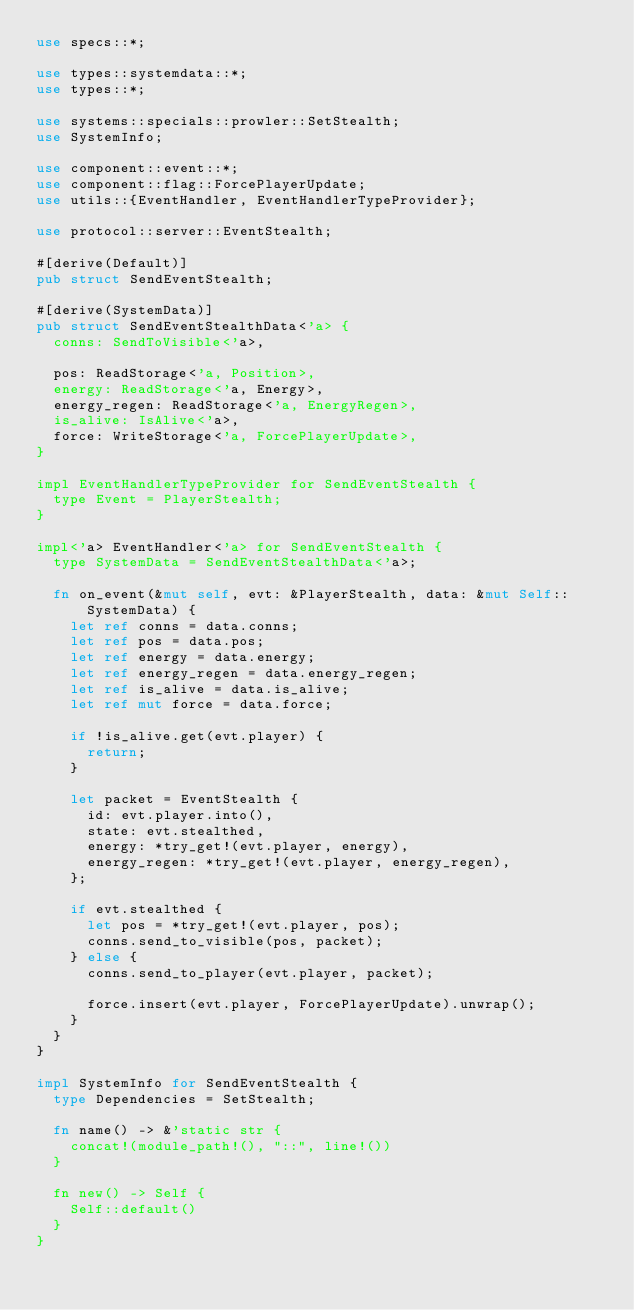Convert code to text. <code><loc_0><loc_0><loc_500><loc_500><_Rust_>use specs::*;

use types::systemdata::*;
use types::*;

use systems::specials::prowler::SetStealth;
use SystemInfo;

use component::event::*;
use component::flag::ForcePlayerUpdate;
use utils::{EventHandler, EventHandlerTypeProvider};

use protocol::server::EventStealth;

#[derive(Default)]
pub struct SendEventStealth;

#[derive(SystemData)]
pub struct SendEventStealthData<'a> {
	conns: SendToVisible<'a>,

	pos: ReadStorage<'a, Position>,
	energy: ReadStorage<'a, Energy>,
	energy_regen: ReadStorage<'a, EnergyRegen>,
	is_alive: IsAlive<'a>,
	force: WriteStorage<'a, ForcePlayerUpdate>,
}

impl EventHandlerTypeProvider for SendEventStealth {
	type Event = PlayerStealth;
}

impl<'a> EventHandler<'a> for SendEventStealth {
	type SystemData = SendEventStealthData<'a>;

	fn on_event(&mut self, evt: &PlayerStealth, data: &mut Self::SystemData) {
		let ref conns = data.conns;
		let ref pos = data.pos;
		let ref energy = data.energy;
		let ref energy_regen = data.energy_regen;
		let ref is_alive = data.is_alive;
		let ref mut force = data.force;

		if !is_alive.get(evt.player) {
			return;
		}

		let packet = EventStealth {
			id: evt.player.into(),
			state: evt.stealthed,
			energy: *try_get!(evt.player, energy),
			energy_regen: *try_get!(evt.player, energy_regen),
		};

		if evt.stealthed {
			let pos = *try_get!(evt.player, pos);
			conns.send_to_visible(pos, packet);
		} else {
			conns.send_to_player(evt.player, packet);

			force.insert(evt.player, ForcePlayerUpdate).unwrap();
		}
	}
}

impl SystemInfo for SendEventStealth {
	type Dependencies = SetStealth;

	fn name() -> &'static str {
		concat!(module_path!(), "::", line!())
	}

	fn new() -> Self {
		Self::default()
	}
}
</code> 